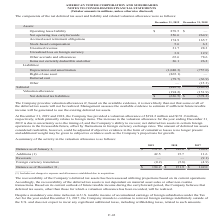According to American Tower Corporation's financial document, When does the company provide valuation allowances? if, based on the available evidence, it is more likely than not that some or all of the deferred tax assets will not be realized.. The document states: "The Company provides valuation allowances if, based on the available evidence, it is more likely than not that some or all of the deferred tax assets ..." Also, What were the Net operating loss carryforwards in 2019? According to the financial document, 356.6 (in millions). The relevant text states: "Net operating loss carryforwards 356.6 264.9..." Also, What was the Stock-based compensation in 2018? According to the financial document, 6.3 (in millions). The relevant text states: "Stock-based compensation 5.6 6.3..." Also, How many components of assets in 2018 were above $100 million? Counting the relevant items in the document: Net operating loss carryforwards, Accrued asset retirement obligations, I find 2 instances. The key data points involved are: Accrued asset retirement obligations, Net operating loss carryforwards. Also, How many components of assets in 2019 were above $50 million? Counting the relevant items in the document:  Operating lease liability , Net operating loss carryforwards, Accrued asset retirement obligations, Other accruals and allowances, I find 4 instances. The key data points involved are: Accrued asset retirement obligations, Net operating loss carryforwards, Operating lease liability. Also, can you calculate: What was the percentage change in Net deferred tax liabilities between 2018 and 2019? To answer this question, I need to perform calculations using the financial data. The calculation is: (-636.5-(-378.2))/-378.2, which equals 68.3 (percentage). This is based on the information: "Net deferred tax liabilities $ (636.5) $ (378.2) Net deferred tax liabilities $ (636.5) $ (378.2)..." The key data points involved are: 378.2, 636.5. 